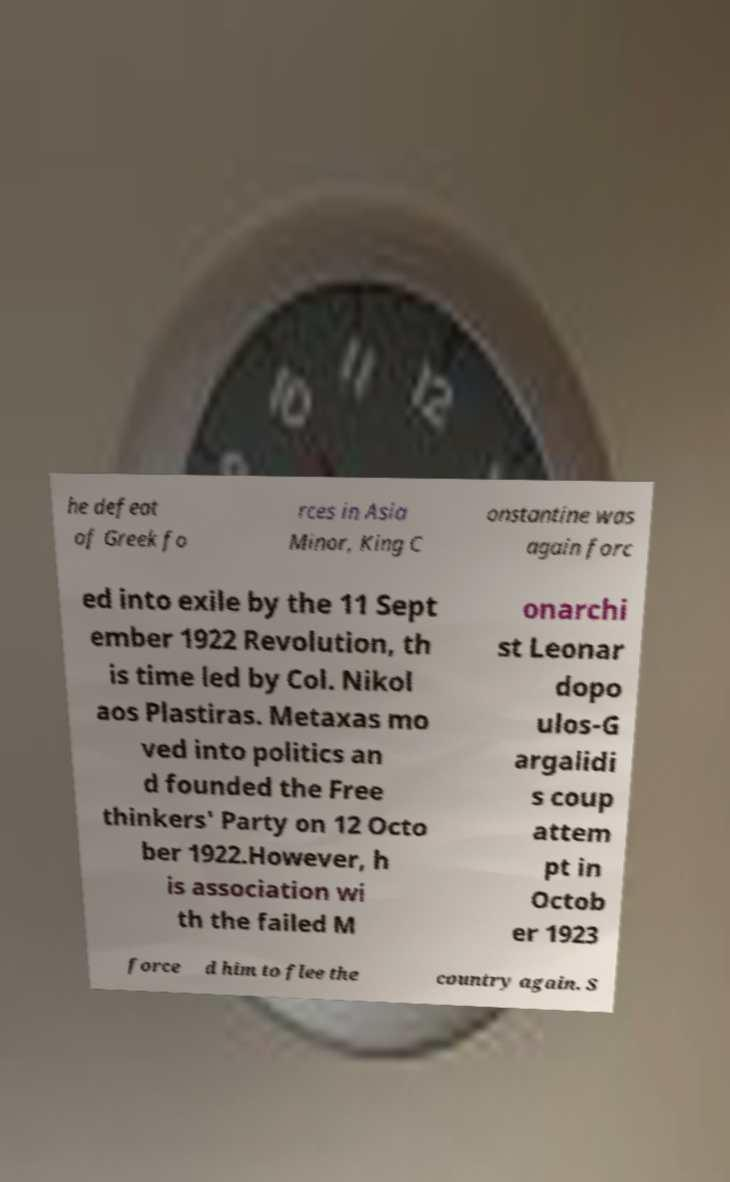I need the written content from this picture converted into text. Can you do that? he defeat of Greek fo rces in Asia Minor, King C onstantine was again forc ed into exile by the 11 Sept ember 1922 Revolution, th is time led by Col. Nikol aos Plastiras. Metaxas mo ved into politics an d founded the Free thinkers' Party on 12 Octo ber 1922.However, h is association wi th the failed M onarchi st Leonar dopo ulos-G argalidi s coup attem pt in Octob er 1923 force d him to flee the country again. S 